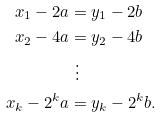<formula> <loc_0><loc_0><loc_500><loc_500>x _ { 1 } - 2 a & = y _ { 1 } - 2 b \\ x _ { 2 } - 4 a & = y _ { 2 } - 4 b \\ & \ \vdots \\ x _ { k } - 2 ^ { k } a & = y _ { k } - 2 ^ { k } b .</formula> 